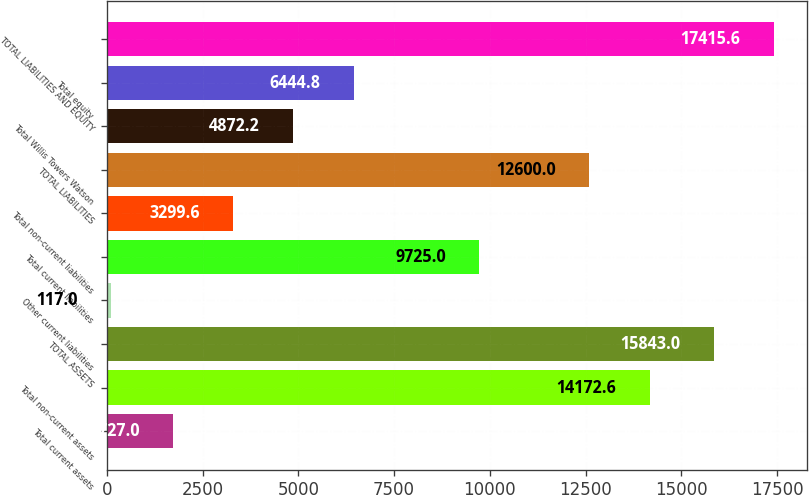Convert chart. <chart><loc_0><loc_0><loc_500><loc_500><bar_chart><fcel>Total current assets<fcel>Total non-current assets<fcel>TOTAL ASSETS<fcel>Other current liabilities<fcel>Total current liabilities<fcel>Total non-current liabilities<fcel>TOTAL LIABILITIES<fcel>Total Willis Towers Watson<fcel>Total equity<fcel>TOTAL LIABILITIES AND EQUITY<nl><fcel>1727<fcel>14172.6<fcel>15843<fcel>117<fcel>9725<fcel>3299.6<fcel>12600<fcel>4872.2<fcel>6444.8<fcel>17415.6<nl></chart> 